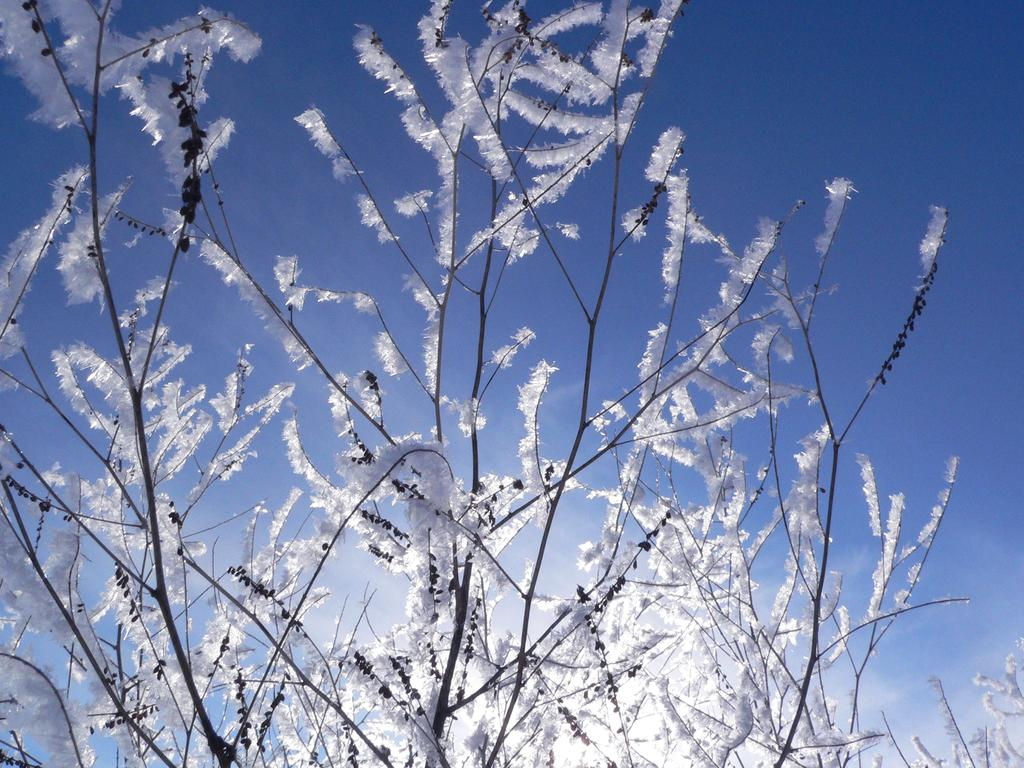What is the main subject of the image? The main subject of the image is a tree with hoar frost. What can be seen in the background of the image? There is a sky visible in the background of the image. What type of feast is being prepared in the image? There is no indication of a feast or any food preparation in the image; it features a tree with hoar frost and a sky in the background. 